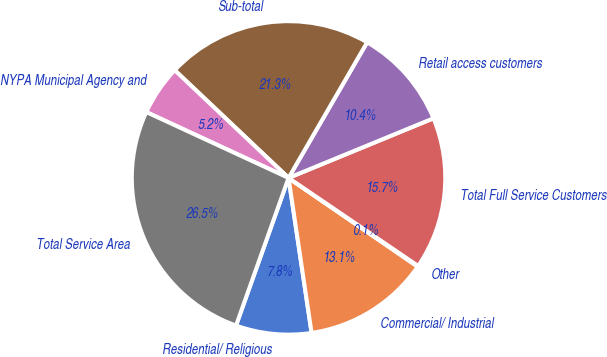Convert chart. <chart><loc_0><loc_0><loc_500><loc_500><pie_chart><fcel>Residential/ Religious<fcel>Commercial/ Industrial<fcel>Other<fcel>Total Full Service Customers<fcel>Retail access customers<fcel>Sub-total<fcel>NYPA Municipal Agency and<fcel>Total Service Area<nl><fcel>7.79%<fcel>13.07%<fcel>0.08%<fcel>15.71%<fcel>10.43%<fcel>21.3%<fcel>5.16%<fcel>26.46%<nl></chart> 